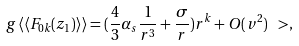Convert formula to latex. <formula><loc_0><loc_0><loc_500><loc_500>g \, \langle \langle F _ { 0 k } ( z _ { 1 } ) \rangle \rangle = ( \frac { 4 } { 3 } \alpha _ { s } \frac { 1 } { r ^ { 3 } } + \frac { \sigma } { r } ) r ^ { k } + O ( v ^ { 2 } ) \ > ,</formula> 